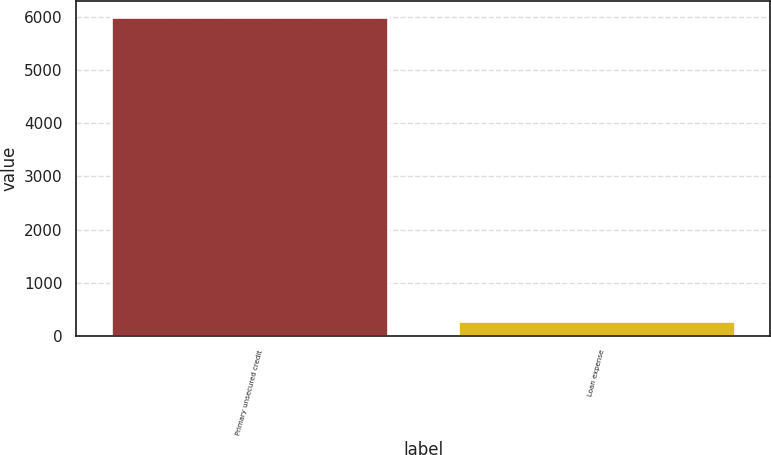Convert chart. <chart><loc_0><loc_0><loc_500><loc_500><bar_chart><fcel>Primary unsecured credit<fcel>Loan expense<nl><fcel>5999<fcel>282<nl></chart> 